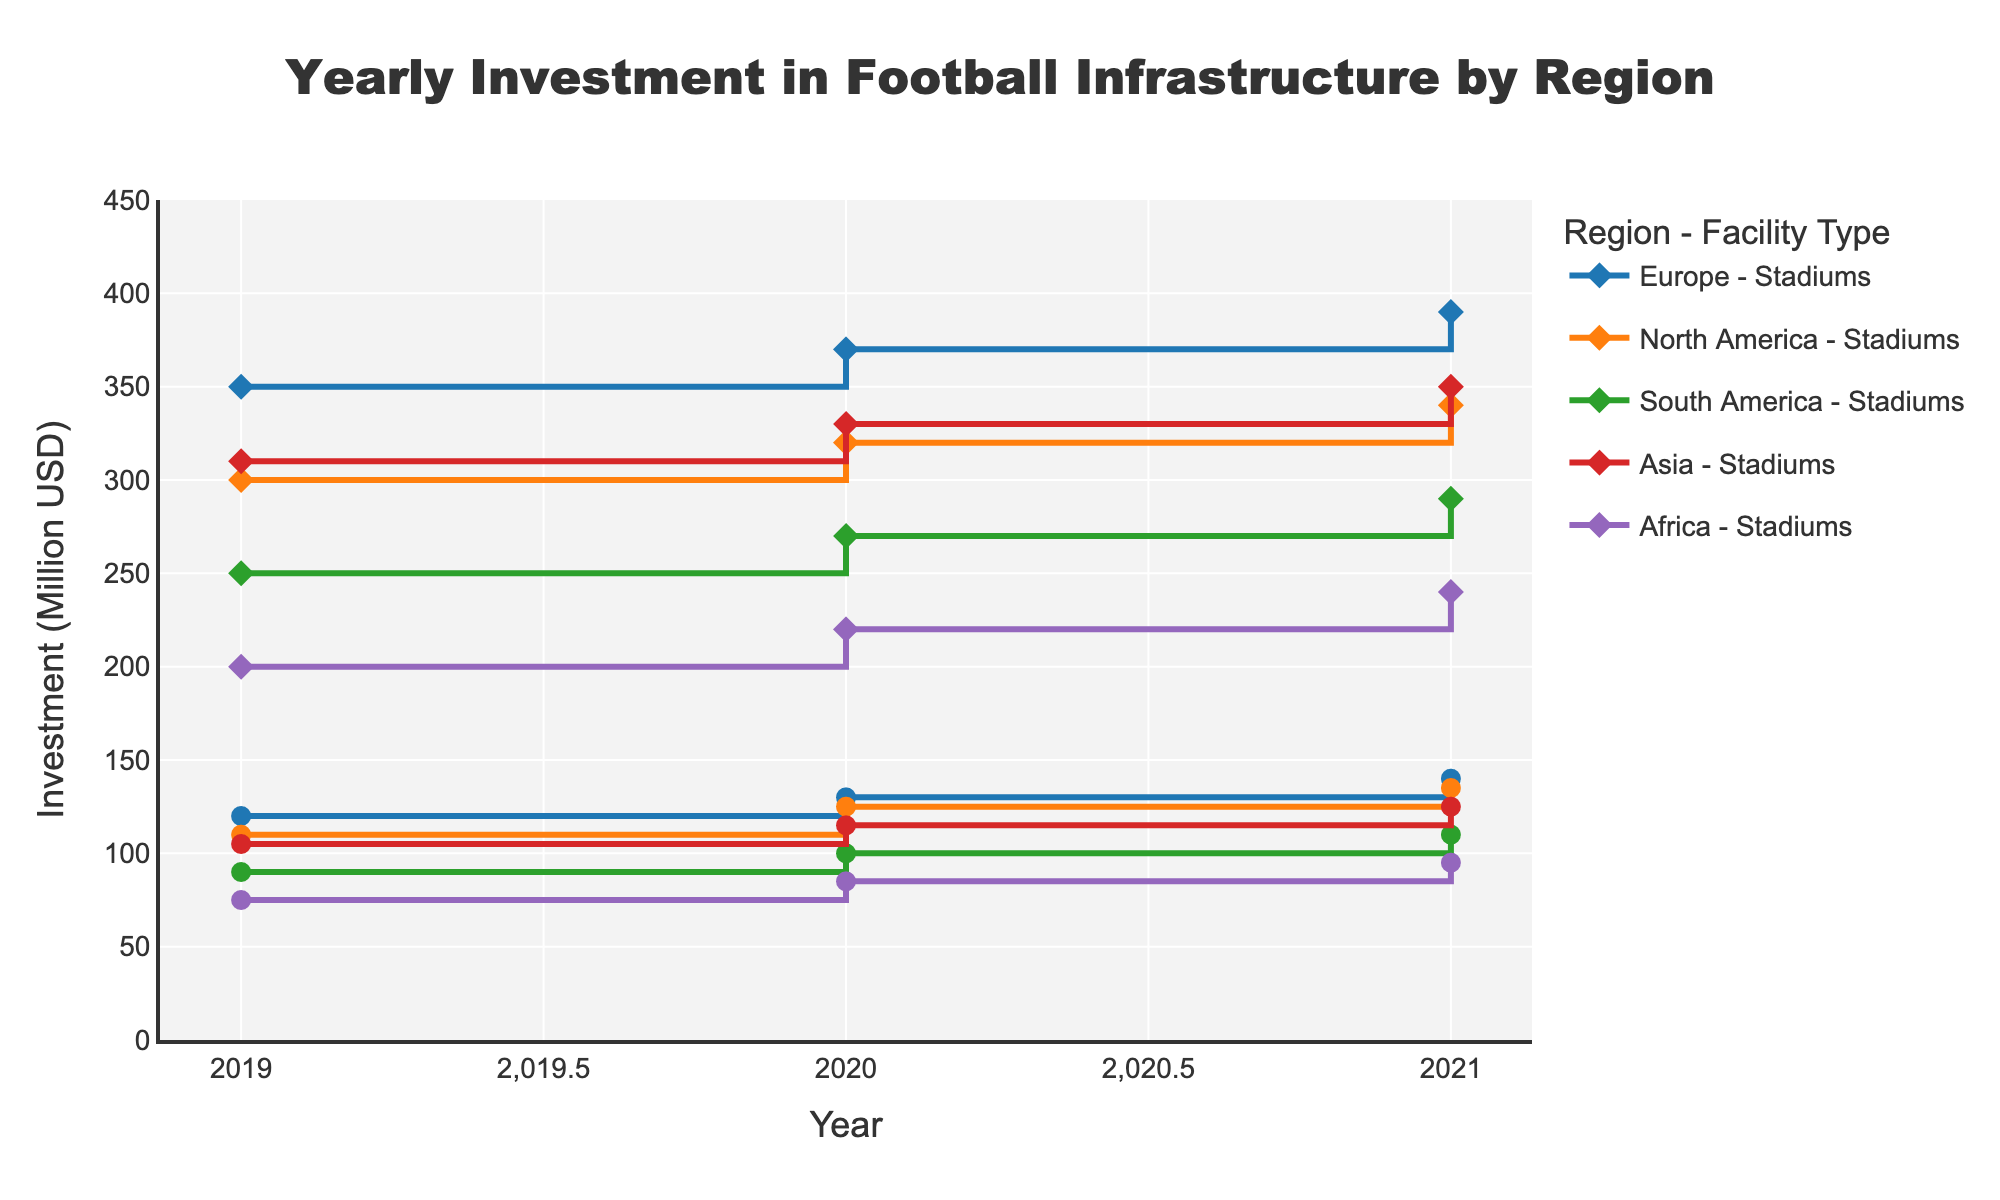What is the title of the plot? The title is shown at the top of the plot. The text is large and centered.
Answer: Yearly Investment in Football Infrastructure by Region Which region had the highest investment in stadiums in 2021? Identify the line corresponding to "Stadiums" for each region and compare the end points. The red line (Asia) is the highest by reaching 350 million USD.
Answer: Asia How much did Europe invest in training grounds in 2020? Find the line representing Europe's "Training Grounds" and locate the marker for the year 2020. The value associated with this marker is 130 million USD.
Answer: 130 million USD Which type of facility had an overall increasing trend in all regions over the years? Check each type of facility across all regions to see if their lines consistently go upwards from 2019 to 2021. Both "Stadiums" and "Training Grounds" facilities show an increasing trend in all regions.
Answer: Stadiums, Training Grounds Which region showed the largest increase in investment in training grounds from 2019 to 2021? Look at the difference between the values of training grounds for each region from 2019 to 2021. Europe shows the largest increase from 120 million USD to 140 million USD (an increase of 20 million USD).
Answer: Europe Compare the total investments in training grounds across all regions in 2021. Which region had the lowest investment? Sum the investments in training grounds for each region in 2021 and identify the lowest value. Africa's investment in training grounds in 2021 was 95 million USD, the lowest among all regions.
Answer: Africa What is the difference in investment between stadiums and training grounds in North America in 2021? Identify the investment values for both stadiums and training grounds in North America in 2021. Subtract the training grounds investment from the stadiums investment: 340 million USD - 135 million USD = 205 million USD.
Answer: 205 million USD In which year did Africa see the highest increase in investment for stadiums compared to the previous year? Compare each year's investment in stadiums for Africa to see which year saw the highest increase from the previous year. The largest increase is seen from 2019 to 2020 (200 million USD to 220 million USD, an increase of 20 million USD).
Answer: 2020 